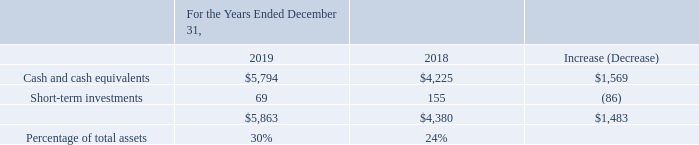Liquidity and Capital Resources
We believe our ability to generate cash flows from operating activities is one of our fundamental financial strengths. In the near term, we expect our business and financial condition to remain strong and to continue to generate significant operating cash flows, which, we believe, in combination with our existing balance of cash and cash equivalents and short-term investments of $5.9 billion, our access to capital, and the availability of our $1.5 billion revolving credit facility, will be sufficient to finance our operational and financing requirements for the next 12 months. Our primary sources of liquidity, which are available to us to fund cash outflows such as potential dividend payments or share repurchases, and scheduled debt maturities, include our cash and cash equivalents, short-term investments, and cash flows provided by operating activities.
As of December 31, 2019, the amount of cash and cash equivalents held outside of the U.S. by our foreign subsidiaries was $2.8 billion, as compared to $1.4 billion as of December 31, 2018. These cash balances are generally available for use in the U.S., subject in some cases to certain restrictions.
Our cash provided from operating activities is somewhat impacted by seasonality. Working capital needs are impacted by weekly sales, which are generally highest in the fourth quarter due to seasonal and holiday-related sales patterns. We consider, on a continuing basis, various transactions to increase shareholder value and enhance our business results, including acquisitions, divestitures, joint ventures, share repurchases, and other structural changes. These transactions may result in future cash proceeds or payments.
Sources of Liquidity (amounts in millions)
What is the cash and cash equivalents in 2019?
Answer scale should be: million. 5,794. What is the cash and cash equivalents in 2018?
Answer scale should be: million. 4,225. What were the short-term investments in 2019?
Answer scale should be: million. 69. What was the percentage change in cash and cash equivalents between 2018 and 2019? 
Answer scale should be: percent. ($5,794-$4,225)/$4,225
Answer: 37.14. What was the percentage change in Short-term investments between 2018 and 2019?
Answer scale should be: percent. (69-155)/155
Answer: -55.48. What percentage of total assets consists of short-term investments in 2019?
Answer scale should be: percent. 69/5,863
Answer: 1.18. 